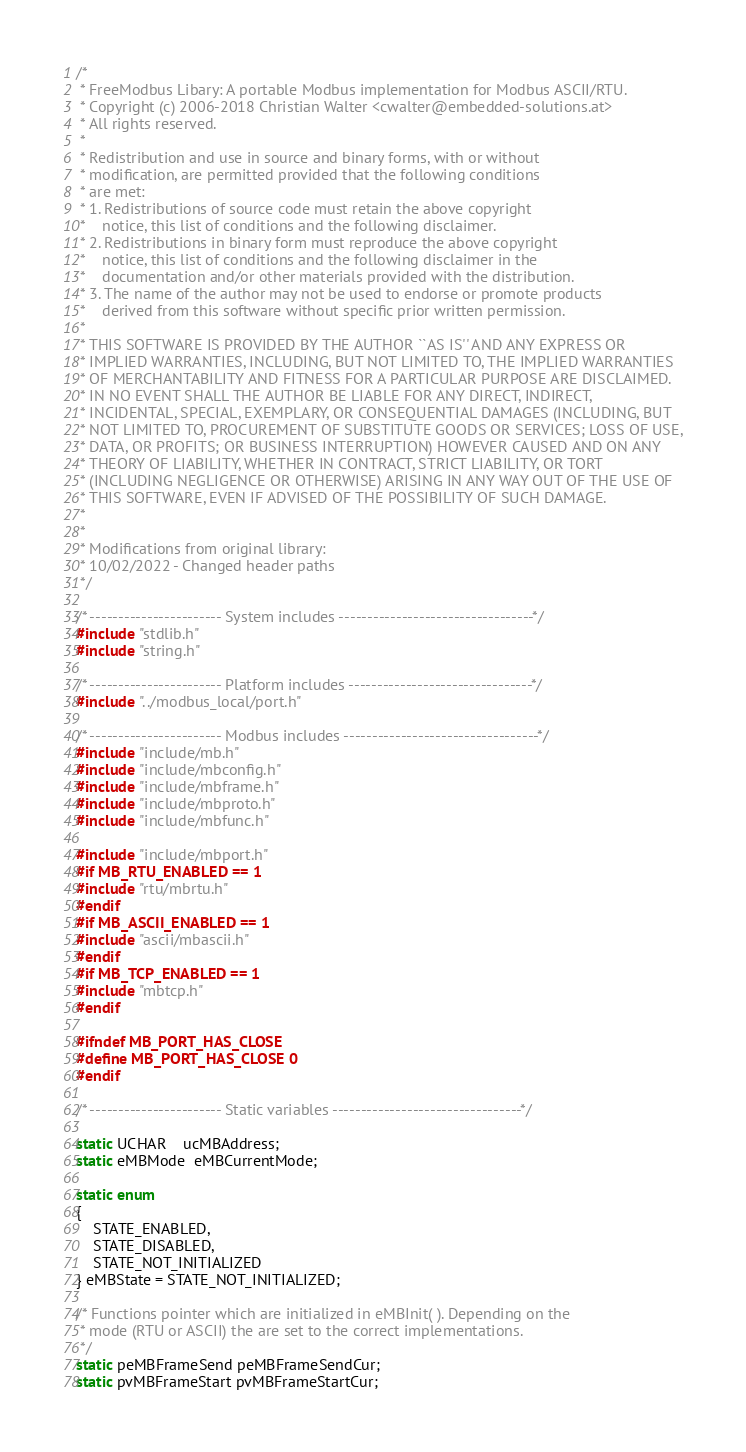Convert code to text. <code><loc_0><loc_0><loc_500><loc_500><_C_>/* 
 * FreeModbus Libary: A portable Modbus implementation for Modbus ASCII/RTU.
 * Copyright (c) 2006-2018 Christian Walter <cwalter@embedded-solutions.at>
 * All rights reserved.
 *
 * Redistribution and use in source and binary forms, with or without
 * modification, are permitted provided that the following conditions
 * are met:
 * 1. Redistributions of source code must retain the above copyright
 *    notice, this list of conditions and the following disclaimer.
 * 2. Redistributions in binary form must reproduce the above copyright
 *    notice, this list of conditions and the following disclaimer in the
 *    documentation and/or other materials provided with the distribution.
 * 3. The name of the author may not be used to endorse or promote products
 *    derived from this software without specific prior written permission.
 *
 * THIS SOFTWARE IS PROVIDED BY THE AUTHOR ``AS IS'' AND ANY EXPRESS OR
 * IMPLIED WARRANTIES, INCLUDING, BUT NOT LIMITED TO, THE IMPLIED WARRANTIES
 * OF MERCHANTABILITY AND FITNESS FOR A PARTICULAR PURPOSE ARE DISCLAIMED.
 * IN NO EVENT SHALL THE AUTHOR BE LIABLE FOR ANY DIRECT, INDIRECT,
 * INCIDENTAL, SPECIAL, EXEMPLARY, OR CONSEQUENTIAL DAMAGES (INCLUDING, BUT
 * NOT LIMITED TO, PROCUREMENT OF SUBSTITUTE GOODS OR SERVICES; LOSS OF USE,
 * DATA, OR PROFITS; OR BUSINESS INTERRUPTION) HOWEVER CAUSED AND ON ANY
 * THEORY OF LIABILITY, WHETHER IN CONTRACT, STRICT LIABILITY, OR TORT
 * (INCLUDING NEGLIGENCE OR OTHERWISE) ARISING IN ANY WAY OUT OF THE USE OF
 * THIS SOFTWARE, EVEN IF ADVISED OF THE POSSIBILITY OF SUCH DAMAGE.
 *
 * 
 * Modifications from original library:
 * 10/02/2022 - Changed header paths
 */

/* ----------------------- System includes ----------------------------------*/
#include "stdlib.h"
#include "string.h"

/* ----------------------- Platform includes --------------------------------*/
#include "../modbus_local/port.h"

/* ----------------------- Modbus includes ----------------------------------*/
#include "include/mb.h"
#include "include/mbconfig.h"
#include "include/mbframe.h"
#include "include/mbproto.h"
#include "include/mbfunc.h"

#include "include/mbport.h"
#if MB_RTU_ENABLED == 1
#include "rtu/mbrtu.h"
#endif
#if MB_ASCII_ENABLED == 1
#include "ascii/mbascii.h"
#endif
#if MB_TCP_ENABLED == 1
#include "mbtcp.h"
#endif

#ifndef MB_PORT_HAS_CLOSE
#define MB_PORT_HAS_CLOSE 0
#endif

/* ----------------------- Static variables ---------------------------------*/

static UCHAR    ucMBAddress;
static eMBMode  eMBCurrentMode;

static enum
{
    STATE_ENABLED,
    STATE_DISABLED,
    STATE_NOT_INITIALIZED
} eMBState = STATE_NOT_INITIALIZED;

/* Functions pointer which are initialized in eMBInit( ). Depending on the
 * mode (RTU or ASCII) the are set to the correct implementations.
 */
static peMBFrameSend peMBFrameSendCur;
static pvMBFrameStart pvMBFrameStartCur;</code> 